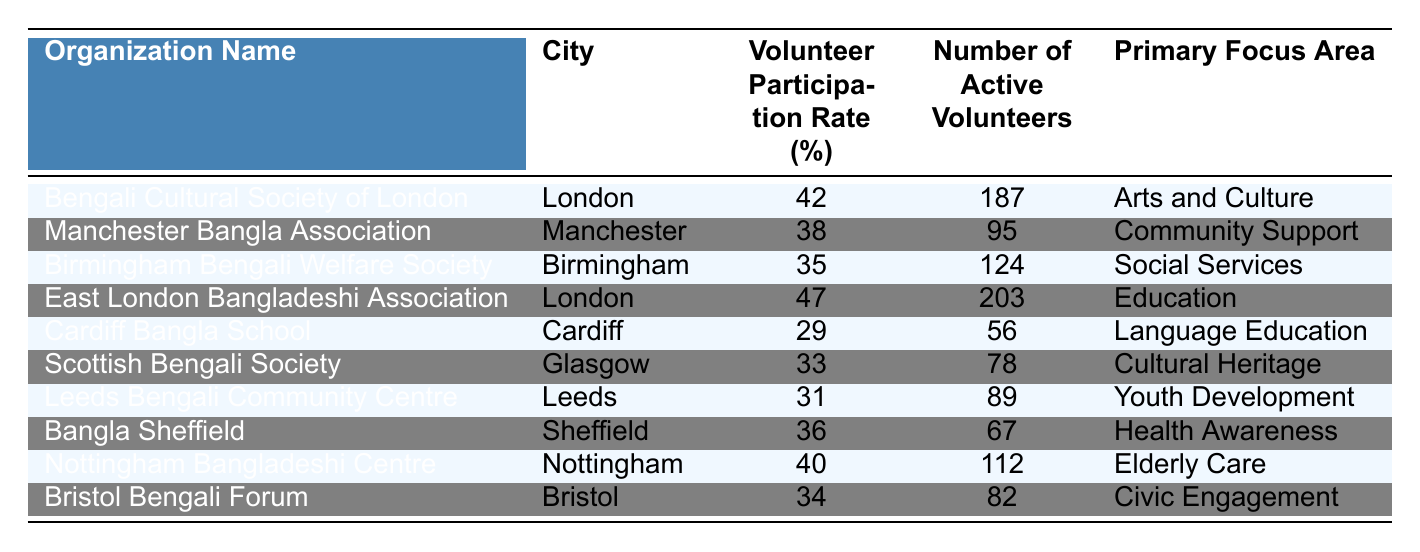What is the highest volunteer participation rate among the organizations listed? The highest figure in the "Volunteer Participation Rate" column is 47%, associated with the 'East London Bangladeshi Association.'
Answer: 47% Which city has the organization with the lowest volunteer participation rate? The organization with the lowest participation rate is 'Cardiff Bangla School' located in Cardiff, with a rate of 29%.
Answer: Cardiff How many active volunteers does the 'Bengali Cultural Society of London' have? By referring to the row for 'Bengali Cultural Society of London,' we see that the number of active volunteers is 187.
Answer: 187 What is the average volunteer participation rate of the organizations in London? The rates for the organizations in London are 42% (Bengali Cultural Society of London) and 47% (East London Bangladeshi Association). Their sum is 89%, and when divided by 2, the average is 44.5%.
Answer: 44.5% Is there an organization in Nottingham with a volunteer participation rate above 35%? The 'Nottingham Bangladeshi Centre' has a participation rate of 40%, which is above 35%. Therefore, the answer is yes.
Answer: Yes What is the total number of active volunteers across all organizations? By summing the number of active volunteers (187 + 95 + 124 + 203 + 56 + 78 + 89 + 67 + 112 + 82), we find a total of 1,012 active volunteers.
Answer: 1012 Which focus area has the highest number of active volunteers? The 'Education' focus area, represented by 'East London Bangladeshi Association,' has the highest active volunteers at 203.
Answer: Education Are there more organizations focused on "Health Awareness" or "Civic Engagement"? There is 1 organization for each focus area: 'Bangla Sheffield' for Health Awareness and 'Bristol Bengali Forum' for Civic Engagement. Both have the same count.
Answer: Equal What is the difference in volunteer participation rates between the highest and lowest-rated organizations? Subtracting the lowest (29% from Cardiff Bangla School) from the highest (47% from East London Bangladeshi Association), we have a difference of 18%.
Answer: 18% Which organization in Birmingham has a participation rate below average, and what is the rate? The average participation rate for all organizations is 36.5%. The 'Birmingham Bengali Welfare Society' has a rate of 35%, which is below average.
Answer: 35% 